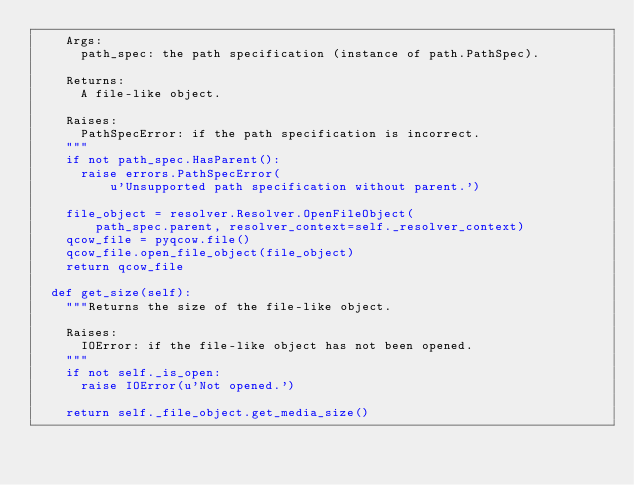<code> <loc_0><loc_0><loc_500><loc_500><_Python_>    Args:
      path_spec: the path specification (instance of path.PathSpec).

    Returns:
      A file-like object.

    Raises:
      PathSpecError: if the path specification is incorrect.
    """
    if not path_spec.HasParent():
      raise errors.PathSpecError(
          u'Unsupported path specification without parent.')

    file_object = resolver.Resolver.OpenFileObject(
        path_spec.parent, resolver_context=self._resolver_context)
    qcow_file = pyqcow.file()
    qcow_file.open_file_object(file_object)
    return qcow_file

  def get_size(self):
    """Returns the size of the file-like object.

    Raises:
      IOError: if the file-like object has not been opened.
    """
    if not self._is_open:
      raise IOError(u'Not opened.')

    return self._file_object.get_media_size()
</code> 